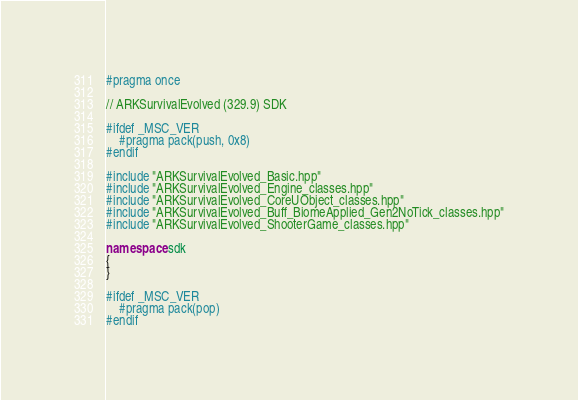Convert code to text. <code><loc_0><loc_0><loc_500><loc_500><_C++_>#pragma once

// ARKSurvivalEvolved (329.9) SDK

#ifdef _MSC_VER
	#pragma pack(push, 0x8)
#endif

#include "ARKSurvivalEvolved_Basic.hpp"
#include "ARKSurvivalEvolved_Engine_classes.hpp"
#include "ARKSurvivalEvolved_CoreUObject_classes.hpp"
#include "ARKSurvivalEvolved_Buff_BiomeApplied_Gen2NoTick_classes.hpp"
#include "ARKSurvivalEvolved_ShooterGame_classes.hpp"

namespace sdk
{
}

#ifdef _MSC_VER
	#pragma pack(pop)
#endif
</code> 